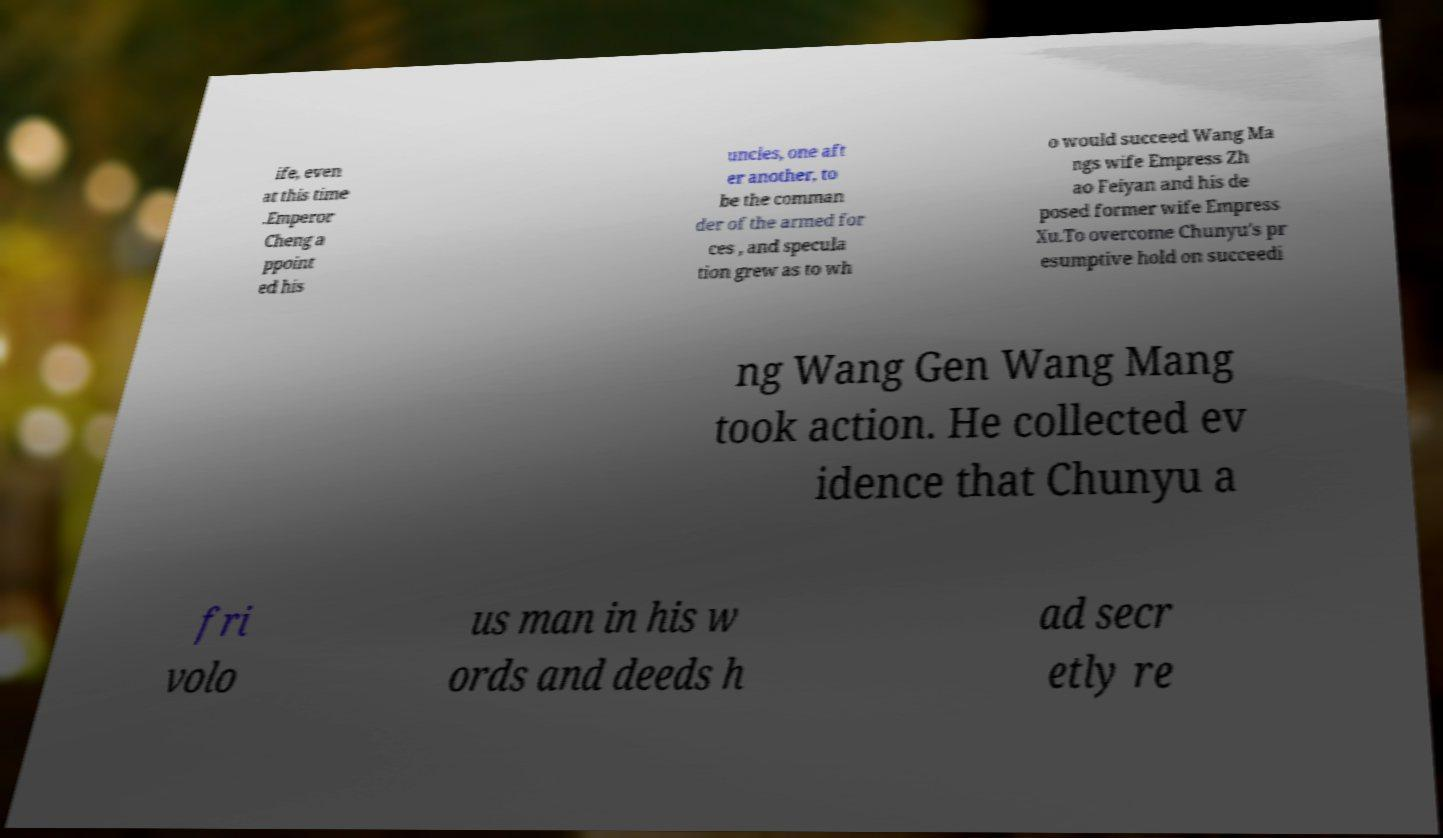Can you accurately transcribe the text from the provided image for me? ife, even at this time .Emperor Cheng a ppoint ed his uncles, one aft er another, to be the comman der of the armed for ces , and specula tion grew as to wh o would succeed Wang Ma ngs wife Empress Zh ao Feiyan and his de posed former wife Empress Xu.To overcome Chunyu's pr esumptive hold on succeedi ng Wang Gen Wang Mang took action. He collected ev idence that Chunyu a fri volo us man in his w ords and deeds h ad secr etly re 